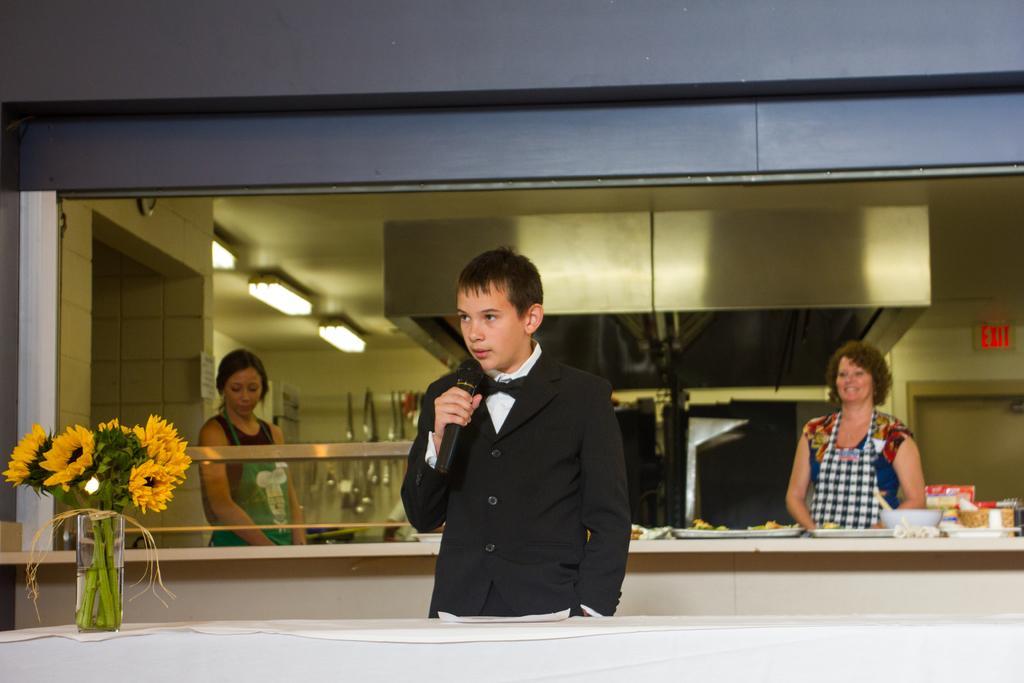Could you give a brief overview of what you see in this image? In this picture we can see a man who is holding a mike with his hand. He is in black color suit, on back of him there are two women are standing. Here we can see a flower bouquet. And this is the glass. And on the background there is a wall and these are the lights. And even we can see some food on the table. 